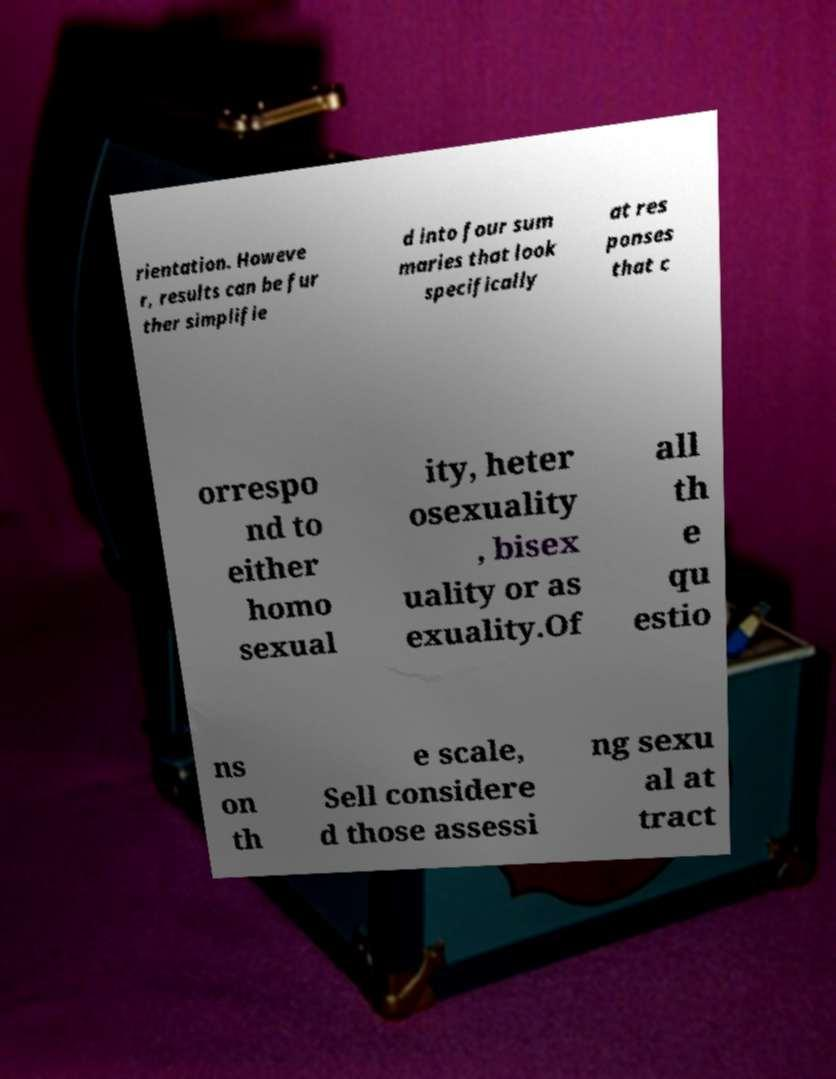There's text embedded in this image that I need extracted. Can you transcribe it verbatim? rientation. Howeve r, results can be fur ther simplifie d into four sum maries that look specifically at res ponses that c orrespo nd to either homo sexual ity, heter osexuality , bisex uality or as exuality.Of all th e qu estio ns on th e scale, Sell considere d those assessi ng sexu al at tract 